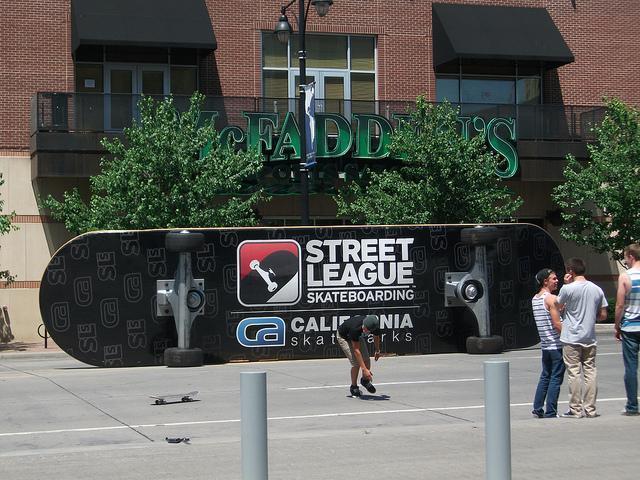How many people are visible?
Give a very brief answer. 4. 